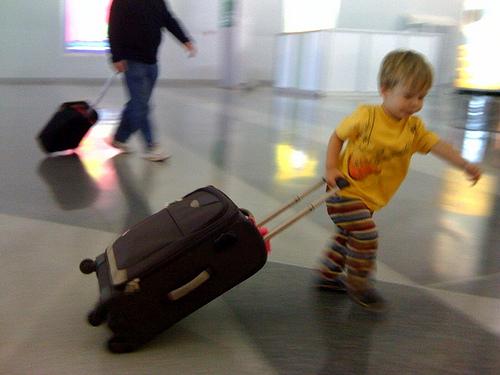What kind of floor is in the picture?
Answer briefly. Tile. Isn't the suitcase too heavy for this little child?
Concise answer only. Yes. Is the kid wearing stripes?
Keep it brief. Yes. 